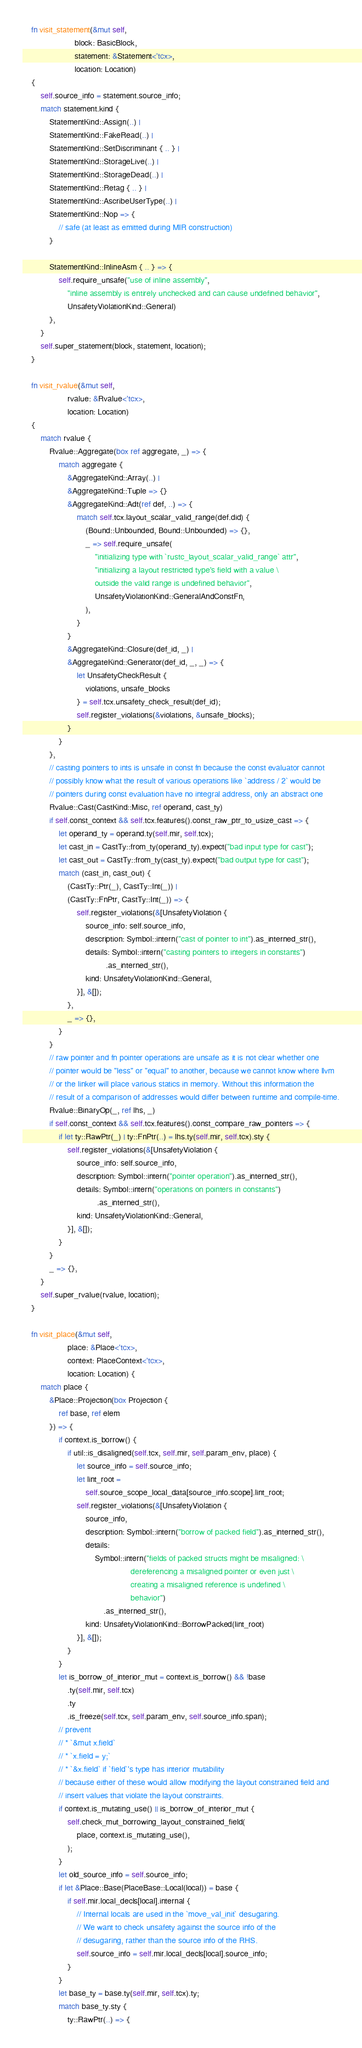Convert code to text. <code><loc_0><loc_0><loc_500><loc_500><_Rust_>
    fn visit_statement(&mut self,
                       block: BasicBlock,
                       statement: &Statement<'tcx>,
                       location: Location)
    {
        self.source_info = statement.source_info;
        match statement.kind {
            StatementKind::Assign(..) |
            StatementKind::FakeRead(..) |
            StatementKind::SetDiscriminant { .. } |
            StatementKind::StorageLive(..) |
            StatementKind::StorageDead(..) |
            StatementKind::Retag { .. } |
            StatementKind::AscribeUserType(..) |
            StatementKind::Nop => {
                // safe (at least as emitted during MIR construction)
            }

            StatementKind::InlineAsm { .. } => {
                self.require_unsafe("use of inline assembly",
                    "inline assembly is entirely unchecked and can cause undefined behavior",
                    UnsafetyViolationKind::General)
            },
        }
        self.super_statement(block, statement, location);
    }

    fn visit_rvalue(&mut self,
                    rvalue: &Rvalue<'tcx>,
                    location: Location)
    {
        match rvalue {
            Rvalue::Aggregate(box ref aggregate, _) => {
                match aggregate {
                    &AggregateKind::Array(..) |
                    &AggregateKind::Tuple => {}
                    &AggregateKind::Adt(ref def, ..) => {
                        match self.tcx.layout_scalar_valid_range(def.did) {
                            (Bound::Unbounded, Bound::Unbounded) => {},
                            _ => self.require_unsafe(
                                "initializing type with `rustc_layout_scalar_valid_range` attr",
                                "initializing a layout restricted type's field with a value \
                                outside the valid range is undefined behavior",
                                UnsafetyViolationKind::GeneralAndConstFn,
                            ),
                        }
                    }
                    &AggregateKind::Closure(def_id, _) |
                    &AggregateKind::Generator(def_id, _, _) => {
                        let UnsafetyCheckResult {
                            violations, unsafe_blocks
                        } = self.tcx.unsafety_check_result(def_id);
                        self.register_violations(&violations, &unsafe_blocks);
                    }
                }
            },
            // casting pointers to ints is unsafe in const fn because the const evaluator cannot
            // possibly know what the result of various operations like `address / 2` would be
            // pointers during const evaluation have no integral address, only an abstract one
            Rvalue::Cast(CastKind::Misc, ref operand, cast_ty)
            if self.const_context && self.tcx.features().const_raw_ptr_to_usize_cast => {
                let operand_ty = operand.ty(self.mir, self.tcx);
                let cast_in = CastTy::from_ty(operand_ty).expect("bad input type for cast");
                let cast_out = CastTy::from_ty(cast_ty).expect("bad output type for cast");
                match (cast_in, cast_out) {
                    (CastTy::Ptr(_), CastTy::Int(_)) |
                    (CastTy::FnPtr, CastTy::Int(_)) => {
                        self.register_violations(&[UnsafetyViolation {
                            source_info: self.source_info,
                            description: Symbol::intern("cast of pointer to int").as_interned_str(),
                            details: Symbol::intern("casting pointers to integers in constants")
                                     .as_interned_str(),
                            kind: UnsafetyViolationKind::General,
                        }], &[]);
                    },
                    _ => {},
                }
            }
            // raw pointer and fn pointer operations are unsafe as it is not clear whether one
            // pointer would be "less" or "equal" to another, because we cannot know where llvm
            // or the linker will place various statics in memory. Without this information the
            // result of a comparison of addresses would differ between runtime and compile-time.
            Rvalue::BinaryOp(_, ref lhs, _)
            if self.const_context && self.tcx.features().const_compare_raw_pointers => {
                if let ty::RawPtr(_) | ty::FnPtr(..) = lhs.ty(self.mir, self.tcx).sty {
                    self.register_violations(&[UnsafetyViolation {
                        source_info: self.source_info,
                        description: Symbol::intern("pointer operation").as_interned_str(),
                        details: Symbol::intern("operations on pointers in constants")
                                 .as_interned_str(),
                        kind: UnsafetyViolationKind::General,
                    }], &[]);
                }
            }
            _ => {},
        }
        self.super_rvalue(rvalue, location);
    }

    fn visit_place(&mut self,
                    place: &Place<'tcx>,
                    context: PlaceContext<'tcx>,
                    location: Location) {
        match place {
            &Place::Projection(box Projection {
                ref base, ref elem
            }) => {
                if context.is_borrow() {
                    if util::is_disaligned(self.tcx, self.mir, self.param_env, place) {
                        let source_info = self.source_info;
                        let lint_root =
                            self.source_scope_local_data[source_info.scope].lint_root;
                        self.register_violations(&[UnsafetyViolation {
                            source_info,
                            description: Symbol::intern("borrow of packed field").as_interned_str(),
                            details:
                                Symbol::intern("fields of packed structs might be misaligned: \
                                                dereferencing a misaligned pointer or even just \
                                                creating a misaligned reference is undefined \
                                                behavior")
                                    .as_interned_str(),
                            kind: UnsafetyViolationKind::BorrowPacked(lint_root)
                        }], &[]);
                    }
                }
                let is_borrow_of_interior_mut = context.is_borrow() && !base
                    .ty(self.mir, self.tcx)
                    .ty
                    .is_freeze(self.tcx, self.param_env, self.source_info.span);
                // prevent
                // * `&mut x.field`
                // * `x.field = y;`
                // * `&x.field` if `field`'s type has interior mutability
                // because either of these would allow modifying the layout constrained field and
                // insert values that violate the layout constraints.
                if context.is_mutating_use() || is_borrow_of_interior_mut {
                    self.check_mut_borrowing_layout_constrained_field(
                        place, context.is_mutating_use(),
                    );
                }
                let old_source_info = self.source_info;
                if let &Place::Base(PlaceBase::Local(local)) = base {
                    if self.mir.local_decls[local].internal {
                        // Internal locals are used in the `move_val_init` desugaring.
                        // We want to check unsafety against the source info of the
                        // desugaring, rather than the source info of the RHS.
                        self.source_info = self.mir.local_decls[local].source_info;
                    }
                }
                let base_ty = base.ty(self.mir, self.tcx).ty;
                match base_ty.sty {
                    ty::RawPtr(..) => {</code> 